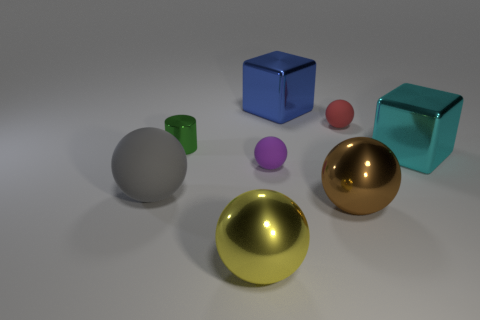What is the material of the yellow object that is the same shape as the purple rubber thing?
Your response must be concise. Metal. What is the shape of the thing that is both in front of the small cylinder and right of the brown sphere?
Your answer should be compact. Cube. The big cyan object that is on the right side of the blue shiny object has what shape?
Give a very brief answer. Cube. What number of balls are in front of the green shiny cylinder and to the right of the blue shiny object?
Offer a terse response. 1. There is a cyan metal cube; does it have the same size as the rubber ball that is behind the metal cylinder?
Your answer should be very brief. No. There is a metal ball that is in front of the metal ball right of the large block that is behind the large cyan metal cube; how big is it?
Offer a very short reply. Large. How big is the metallic ball behind the yellow ball?
Ensure brevity in your answer.  Large. What shape is the small red thing that is made of the same material as the gray thing?
Your answer should be very brief. Sphere. Are the large ball that is left of the big yellow sphere and the brown ball made of the same material?
Offer a terse response. No. How many other objects are the same material as the gray object?
Offer a very short reply. 2. 